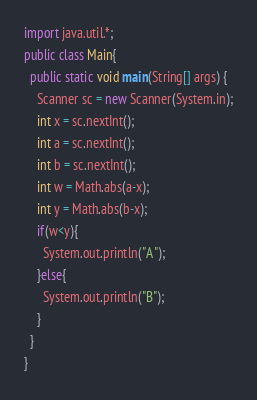Convert code to text. <code><loc_0><loc_0><loc_500><loc_500><_Java_>import java.util.*;
public class Main{
  public static void main(String[] args) {
    Scanner sc = new Scanner(System.in);
    int x = sc.nextInt();
    int a = sc.nextInt();
    int b = sc.nextInt();
    int w = Math.abs(a-x);
    int y = Math.abs(b-x);
    if(w<y){
      System.out.println("A");
    }else{
      System.out.println("B");
    }
  }
}
</code> 